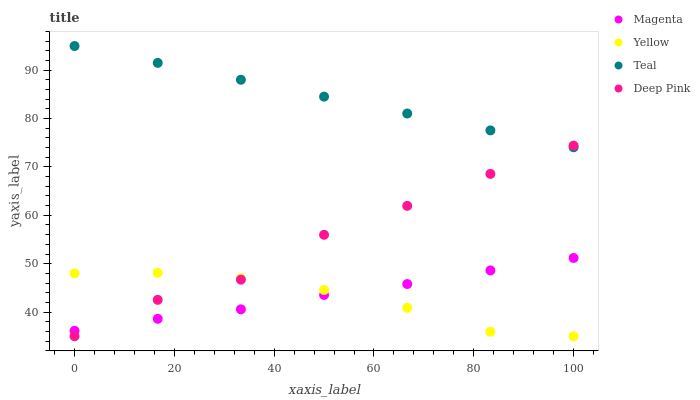Does Yellow have the minimum area under the curve?
Answer yes or no. Yes. Does Teal have the maximum area under the curve?
Answer yes or no. Yes. Does Deep Pink have the minimum area under the curve?
Answer yes or no. No. Does Deep Pink have the maximum area under the curve?
Answer yes or no. No. Is Teal the smoothest?
Answer yes or no. Yes. Is Deep Pink the roughest?
Answer yes or no. Yes. Is Deep Pink the smoothest?
Answer yes or no. No. Is Teal the roughest?
Answer yes or no. No. Does Deep Pink have the lowest value?
Answer yes or no. Yes. Does Teal have the lowest value?
Answer yes or no. No. Does Teal have the highest value?
Answer yes or no. Yes. Does Deep Pink have the highest value?
Answer yes or no. No. Is Magenta less than Teal?
Answer yes or no. Yes. Is Teal greater than Magenta?
Answer yes or no. Yes. Does Deep Pink intersect Magenta?
Answer yes or no. Yes. Is Deep Pink less than Magenta?
Answer yes or no. No. Is Deep Pink greater than Magenta?
Answer yes or no. No. Does Magenta intersect Teal?
Answer yes or no. No. 